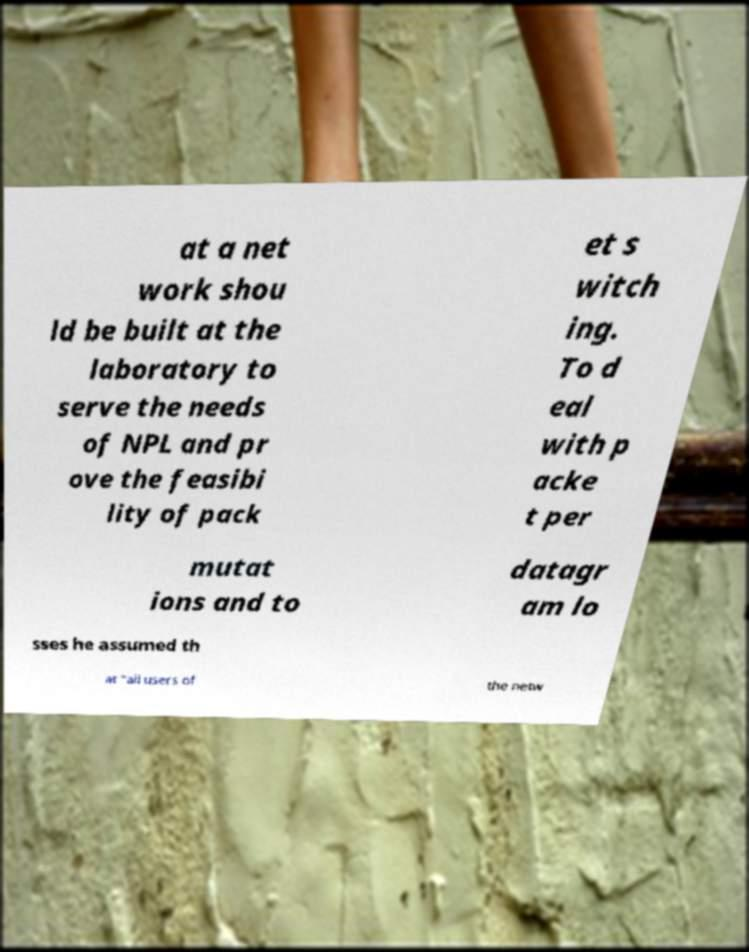There's text embedded in this image that I need extracted. Can you transcribe it verbatim? at a net work shou ld be built at the laboratory to serve the needs of NPL and pr ove the feasibi lity of pack et s witch ing. To d eal with p acke t per mutat ions and to datagr am lo sses he assumed th at "all users of the netw 